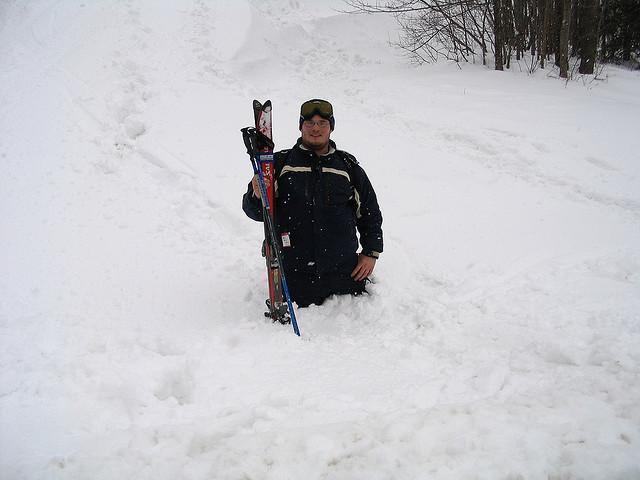How many kites in the sky?
Give a very brief answer. 0. 